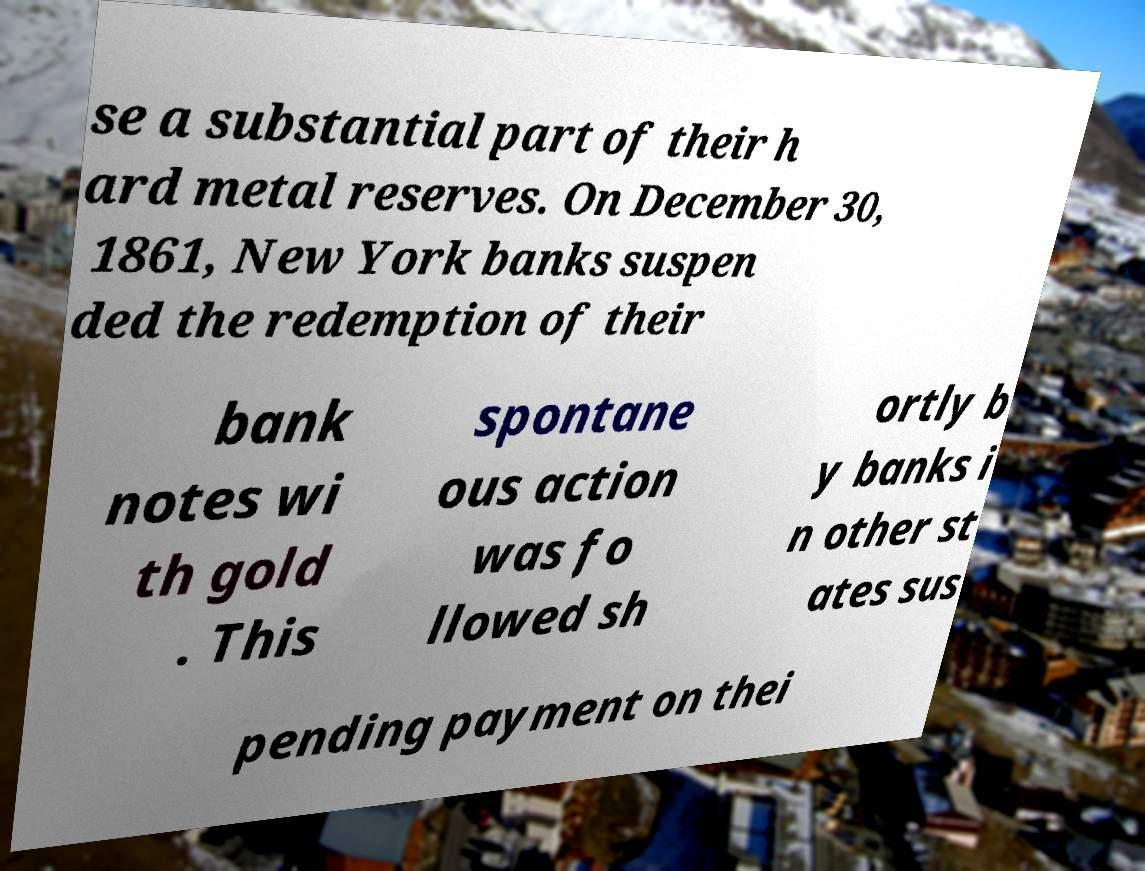Can you read and provide the text displayed in the image?This photo seems to have some interesting text. Can you extract and type it out for me? se a substantial part of their h ard metal reserves. On December 30, 1861, New York banks suspen ded the redemption of their bank notes wi th gold . This spontane ous action was fo llowed sh ortly b y banks i n other st ates sus pending payment on thei 